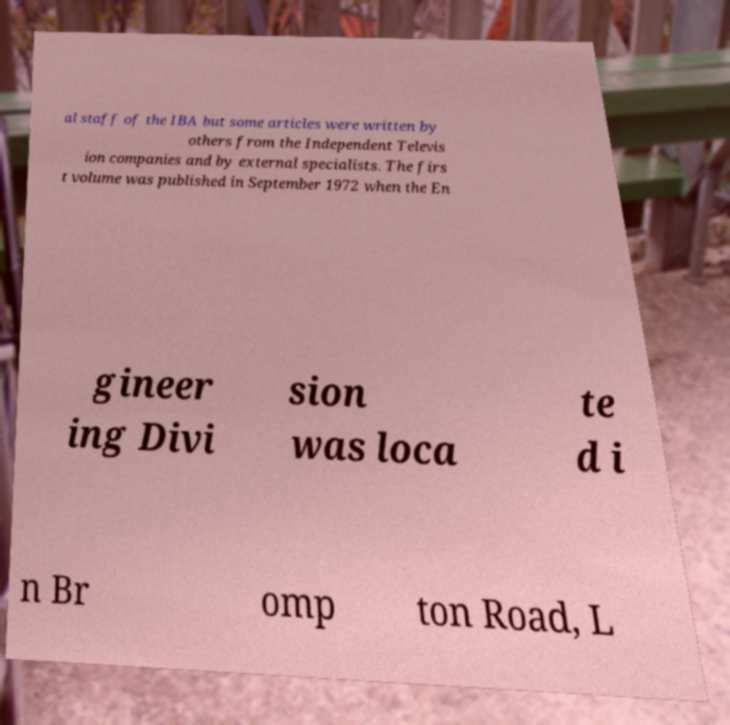Could you extract and type out the text from this image? al staff of the IBA but some articles were written by others from the Independent Televis ion companies and by external specialists. The firs t volume was published in September 1972 when the En gineer ing Divi sion was loca te d i n Br omp ton Road, L 